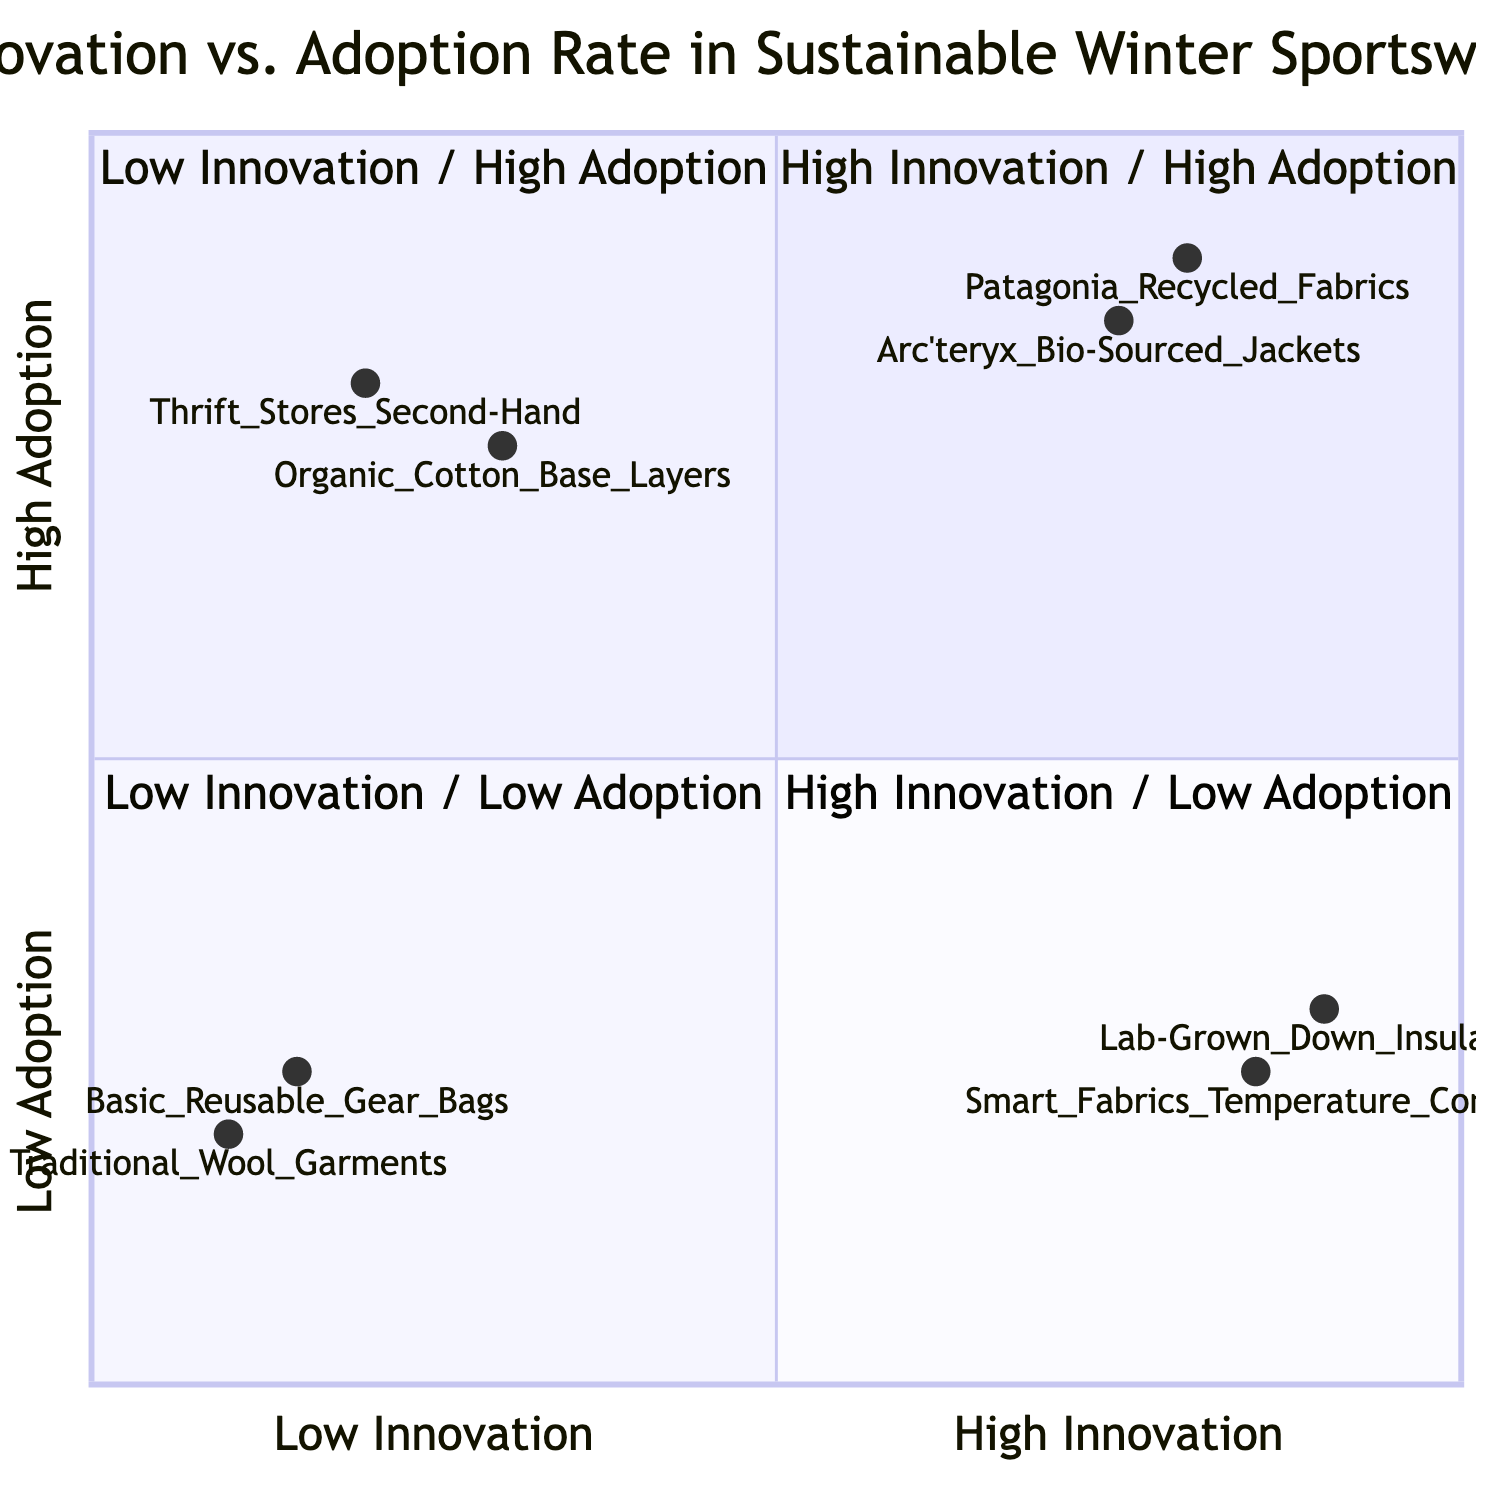What are the examples in the High Innovation / High Adoption quadrant? The High Innovation / High Adoption quadrant includes Patagonia Recycled Fabrics and Arc'teryx Bio-Sourced Jackets as examples.
Answer: Patagonia Recycled Fabrics, Arc'teryx Bio-Sourced Jackets How many examples are in the Low Innovation / Low Adoption quadrant? The Low Innovation / Low Adoption quadrant contains two examples: Traditional Wool Garments and Basic Reusable Gear Bags, leading to a total of two examples.
Answer: 2 Which example has the highest adoption rate in the High Innovation / High Adoption quadrant? Among the examples in the High Innovation / High Adoption quadrant, Arc'teryx Bio-Sourced Jackets have an adoption rate of 0.85, which is higher than Patagonia Recycled Fabrics at 0.9 in innovation but lower in adoption.
Answer: Arc'teryx Bio-Sourced Jackets What is the innovation score of the Lab-Grown Down Insulation? Lab-Grown Down Insulation has an innovation score of 0.9 as shown in the diagram.
Answer: 0.9 Which quadrant contains Smart Fabrics with Temperature Control? Smart Fabrics with Temperature Control is located in the High Innovation / Low Adoption quadrant, based on its position in the provided data.
Answer: High Innovation / Low Adoption What is the common feature of the examples in the Low Innovation / High Adoption quadrant? The examples in the Low Innovation / High Adoption quadrant, such as Thrift Stores and Second-Hand or Organic Cotton Base Layers, focus on accessible sustainability options rather than innovative technologies.
Answer: Accessibility Which quadrant has the lowest innovation and adoption scores? The Low Innovation / Low Adoption quadrant is where Traditional Wool Garments and Basic Reusable Gear Bags are categorized, reflecting the lowest scores for both innovation and adoption.
Answer: Low Innovation / Low Adoption What is the adoption rate of Organic Cotton Base Layers? Organic Cotton Base Layers have an adoption rate of 0.75, based on its data point in the Low Innovation / High Adoption quadrant.
Answer: 0.75 Which example represents the highest innovation without much adoption in the diagram? Lab-Grown Down Insulation, with a high innovation score of 0.9 but a low adoption score of 0.3, exemplifies this scenario.
Answer: Lab-Grown Down Insulation 